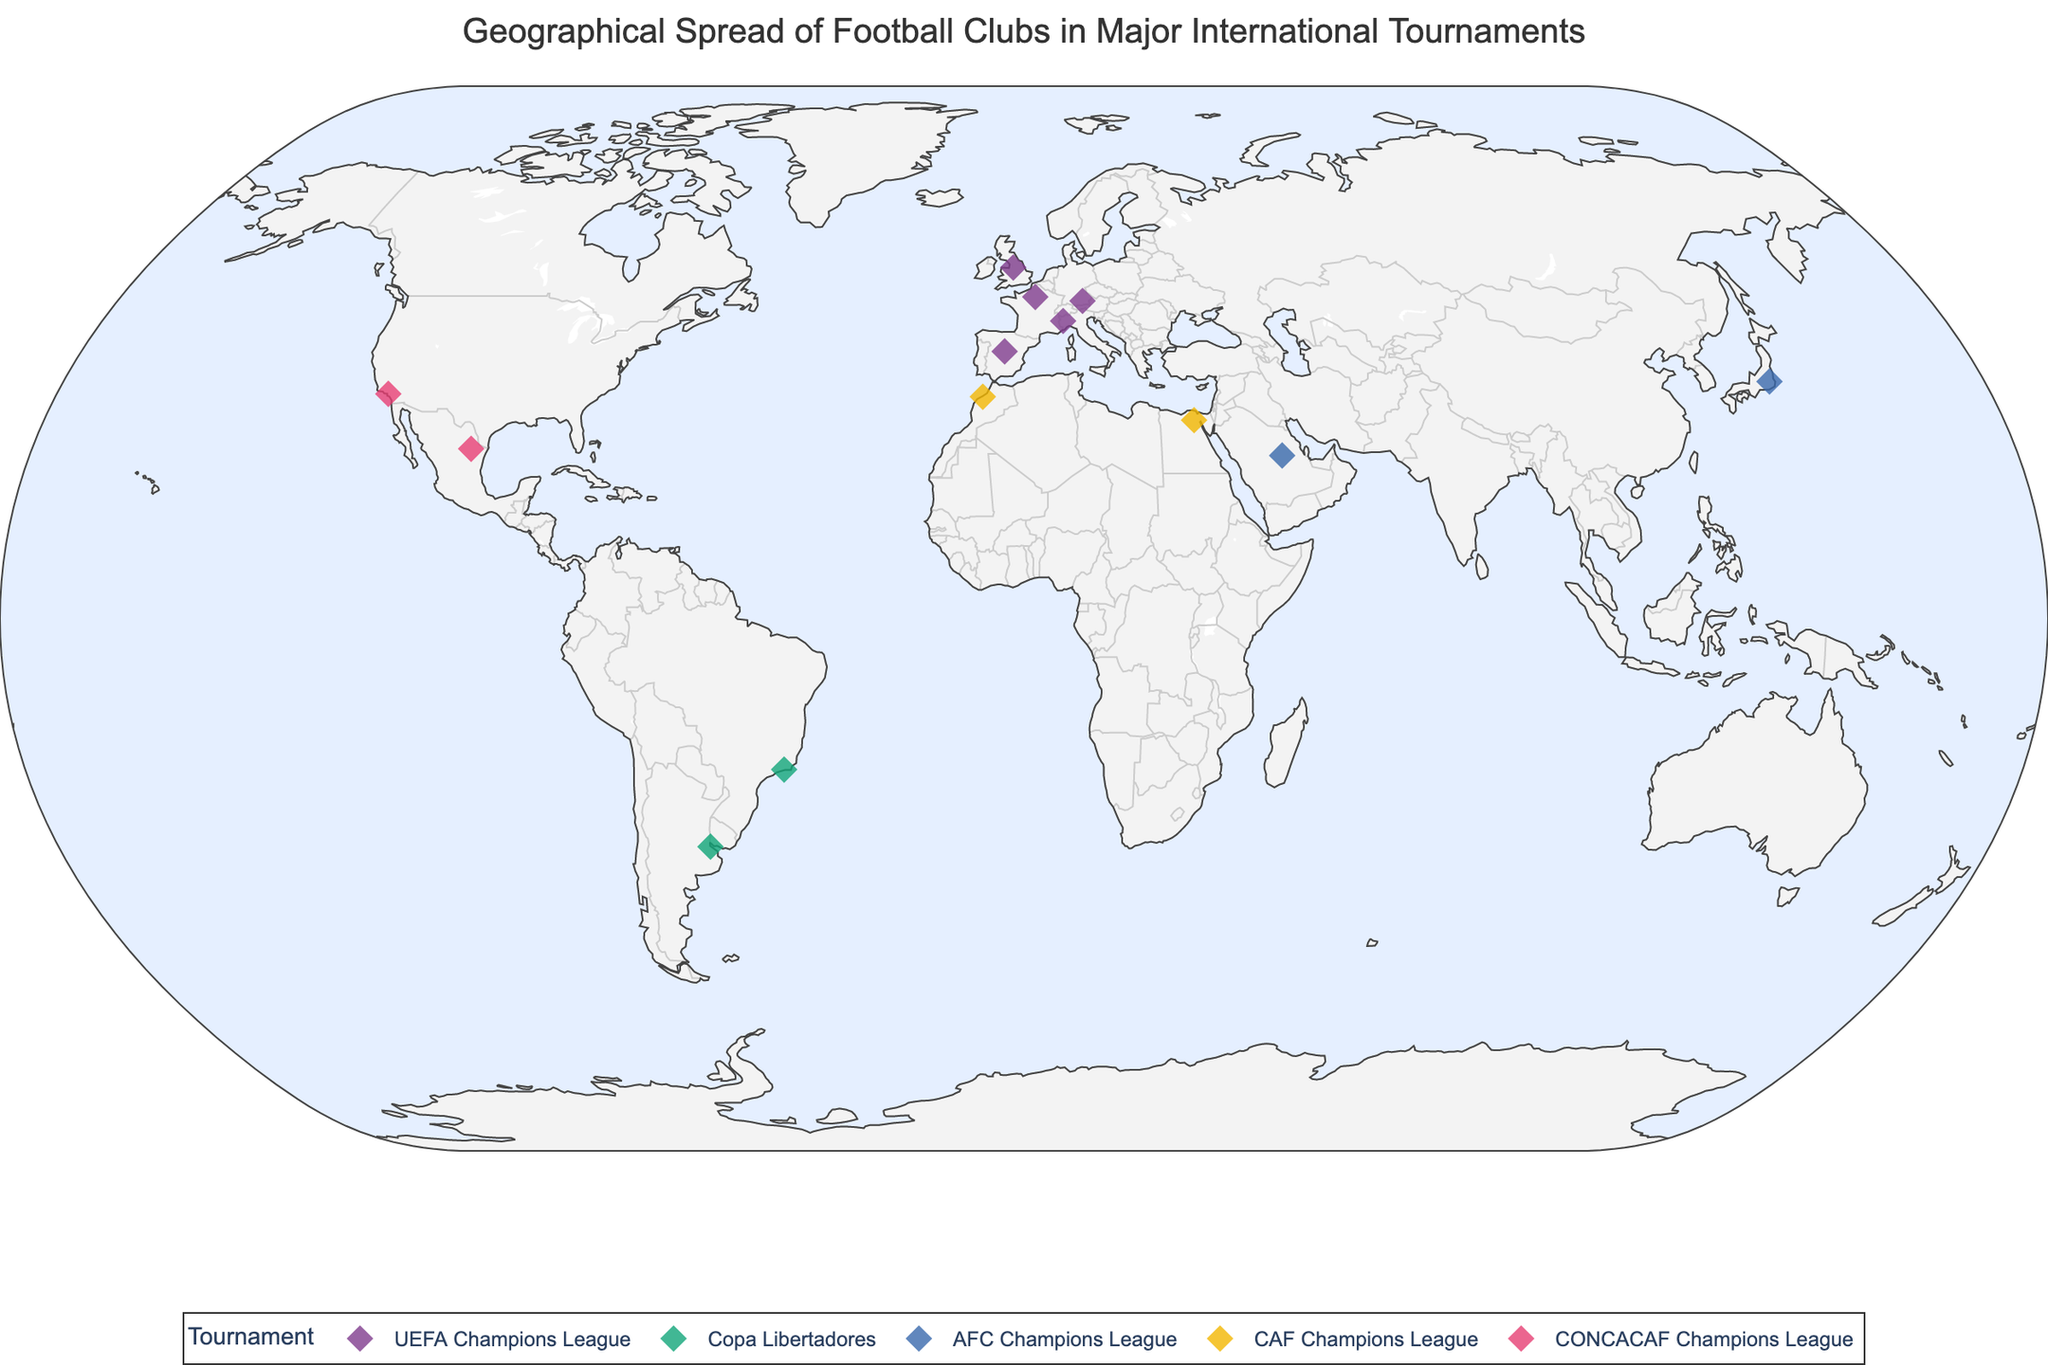What is the title of the plot? The title is located at the top of the plot. By looking at that area, we can read the title, which is directly displayed.
Answer: Geographical Spread of Football Clubs in Major International Tournaments How many clubs are participating in the UEFA Champions League? The clubs participating in the UEFA Champions League are displayed in one color. By identifying and counting these clubs on the plot, we can get the answer.
Answer: 5 Which club is the southernmost participant in the Copa Libertadores? Locate the clubs participating in the Copa Libertadores by their color. Identify the club that is the furthest south by checking their position on the map.
Answer: River Plate Which country has the most clubs participating, and how many are there? We can assess the quantity of clubs per country by looking at each club's location and country label. The country with the highest number of clubs has the most participants.
Answer: Spain, 1 Which tournament has representation from the greatest number of continents? To find this, check the distribution of clubs and their tournaments across different continents. Count the continents represented in each tournament.
Answer: AFC Champions League Which two clubs are geographically closest? We can visually inspect the plot to find clubs that are located near each other. Check the distances between all clubs and identify the smallest distance.
Answer: Paris Saint-Germain and Bayern Munich Which tournament has the northernmost club? Identify the northernmost point on the plot and check which club and tournament are located there.
Answer: UEFA Champions League How many continents are represented in the plot? By examining the geographical locations of all clubs, we can count the number of distinct continents.
Answer: 5 Which club is positioned furthest to the east? Locate the easternmost point on the map and identify which club is located at this position.
Answer: Urawa Red Diamonds Which club is positioned furthest to the west? Locate the westernmost point on the map and identify which club is located at this position.
Answer: LAFC 